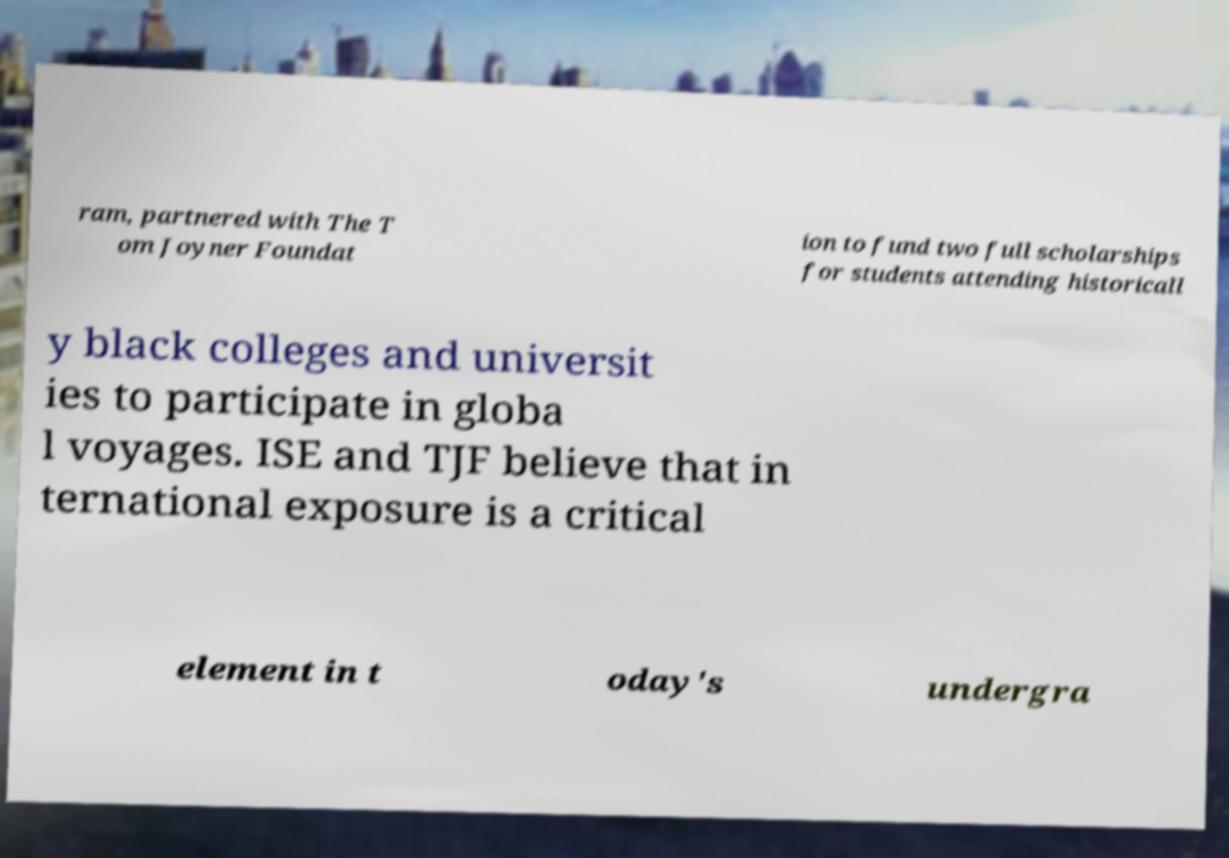I need the written content from this picture converted into text. Can you do that? ram, partnered with The T om Joyner Foundat ion to fund two full scholarships for students attending historicall y black colleges and universit ies to participate in globa l voyages. ISE and TJF believe that in ternational exposure is a critical element in t oday's undergra 